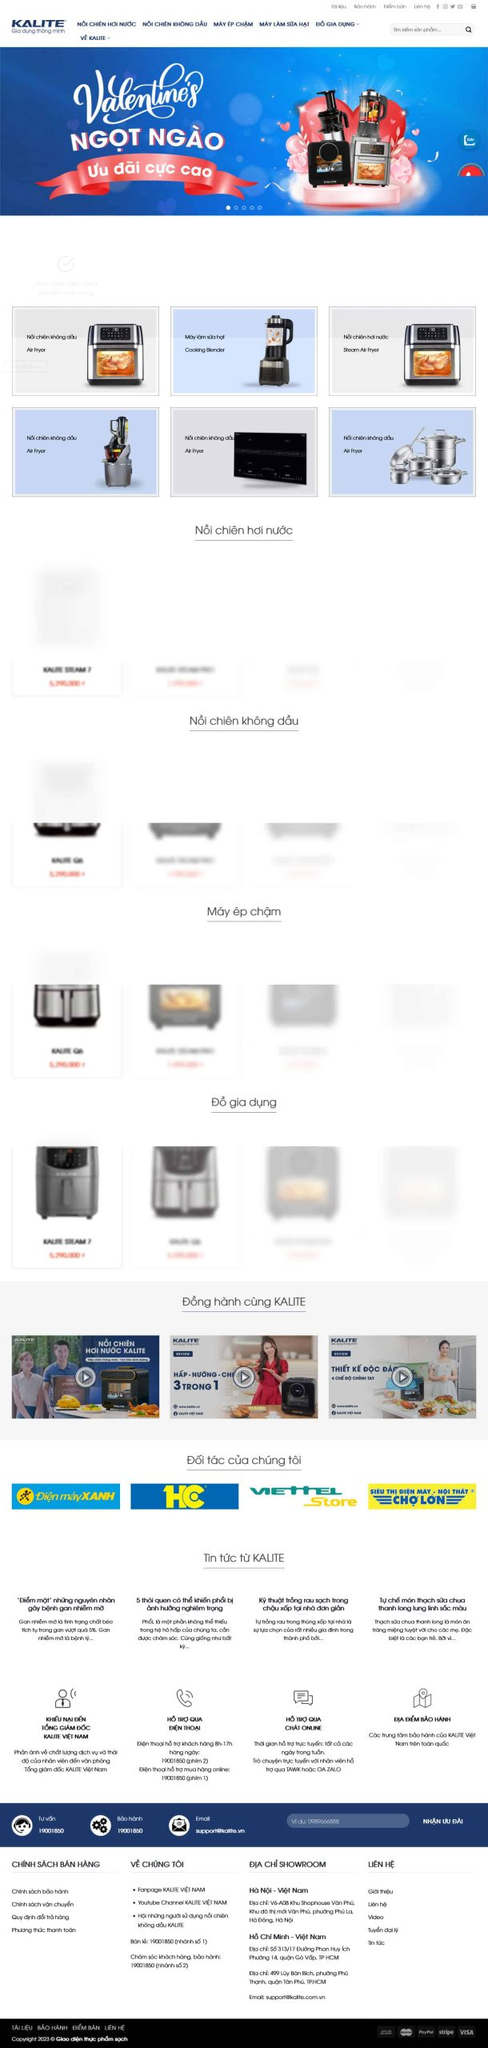Liệt kê 5 ngành nghề, lĩnh vực phù hợp với website này, phân cách các màu sắc bằng dấu phẩy. Chỉ trả về kết quả, phân cách bằng dấy phẩy
 Nội trợ, gia dụng, điện máy, thiết bị nhà bếp, dịch vụ bảo hành 